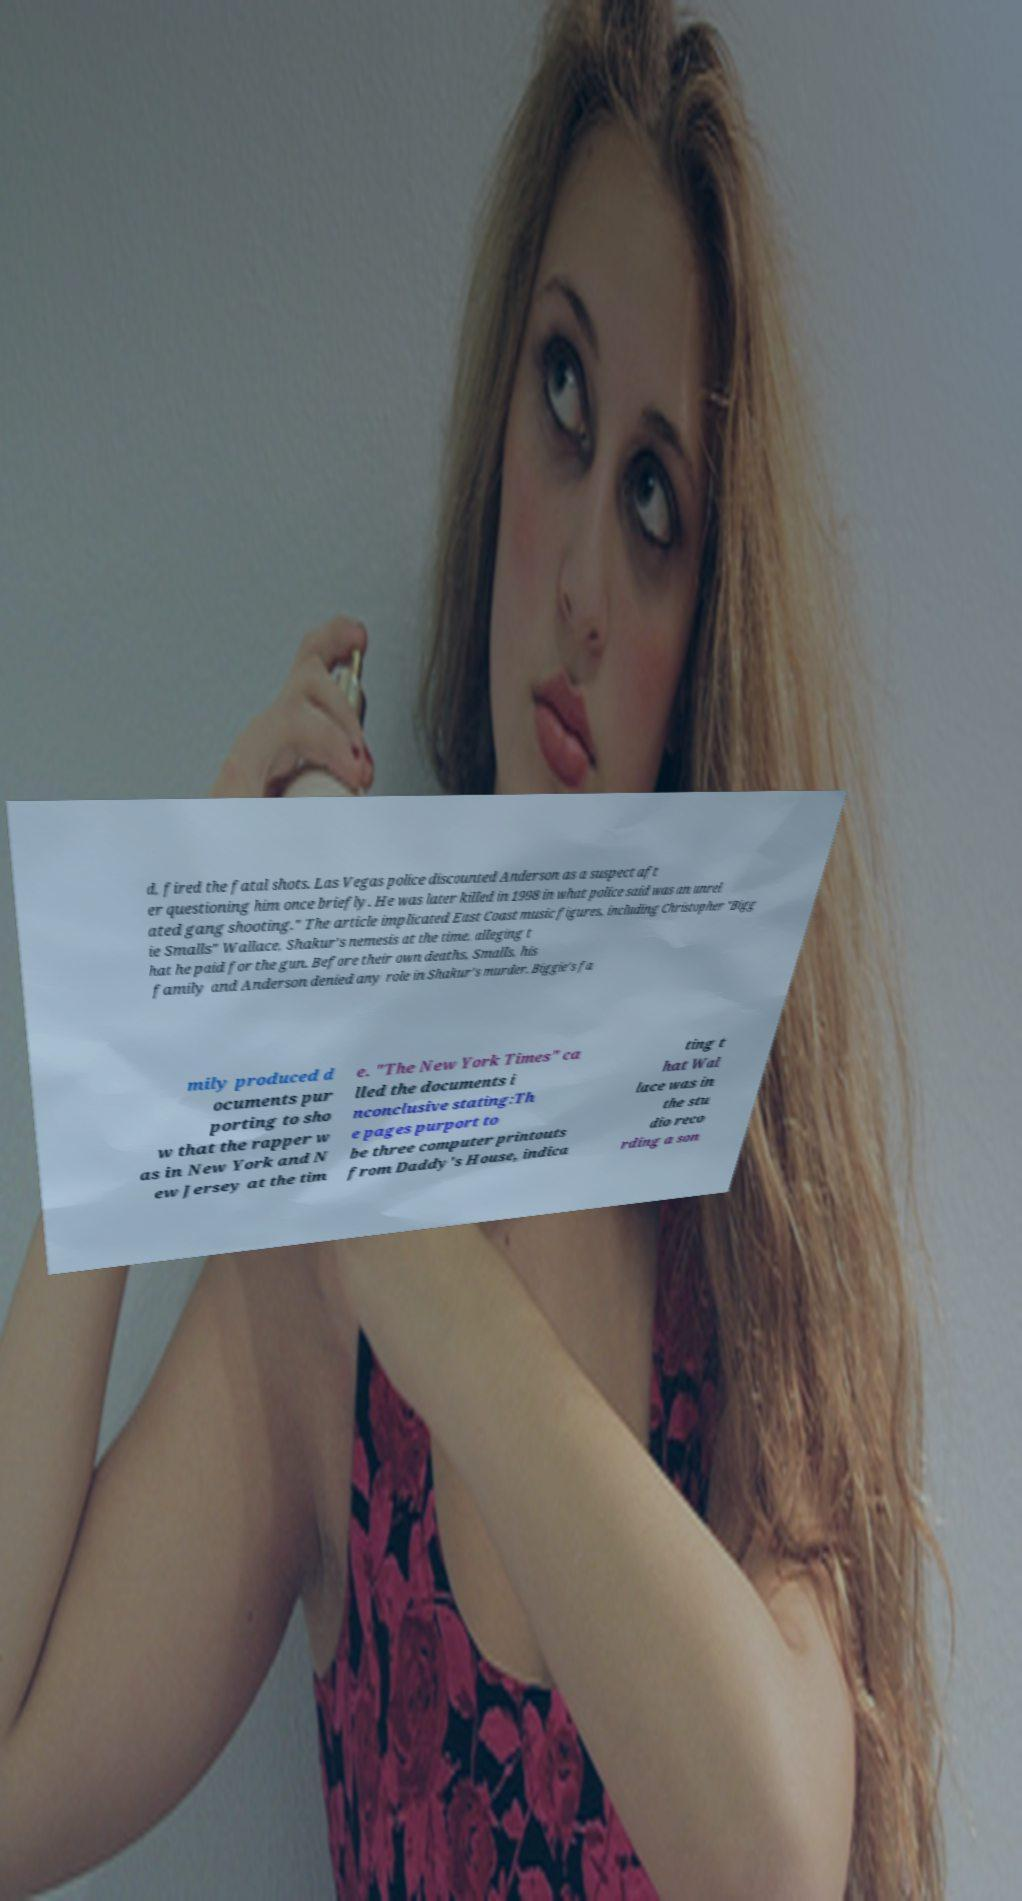Please read and relay the text visible in this image. What does it say? d, fired the fatal shots. Las Vegas police discounted Anderson as a suspect aft er questioning him once briefly. He was later killed in 1998 in what police said was an unrel ated gang shooting." The article implicated East Coast music figures, including Christopher "Bigg ie Smalls" Wallace, Shakur's nemesis at the time, alleging t hat he paid for the gun. Before their own deaths, Smalls, his family and Anderson denied any role in Shakur's murder. Biggie's fa mily produced d ocuments pur porting to sho w that the rapper w as in New York and N ew Jersey at the tim e. "The New York Times" ca lled the documents i nconclusive stating:Th e pages purport to be three computer printouts from Daddy's House, indica ting t hat Wal lace was in the stu dio reco rding a son 